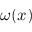<formula> <loc_0><loc_0><loc_500><loc_500>\omega ( x )</formula> 